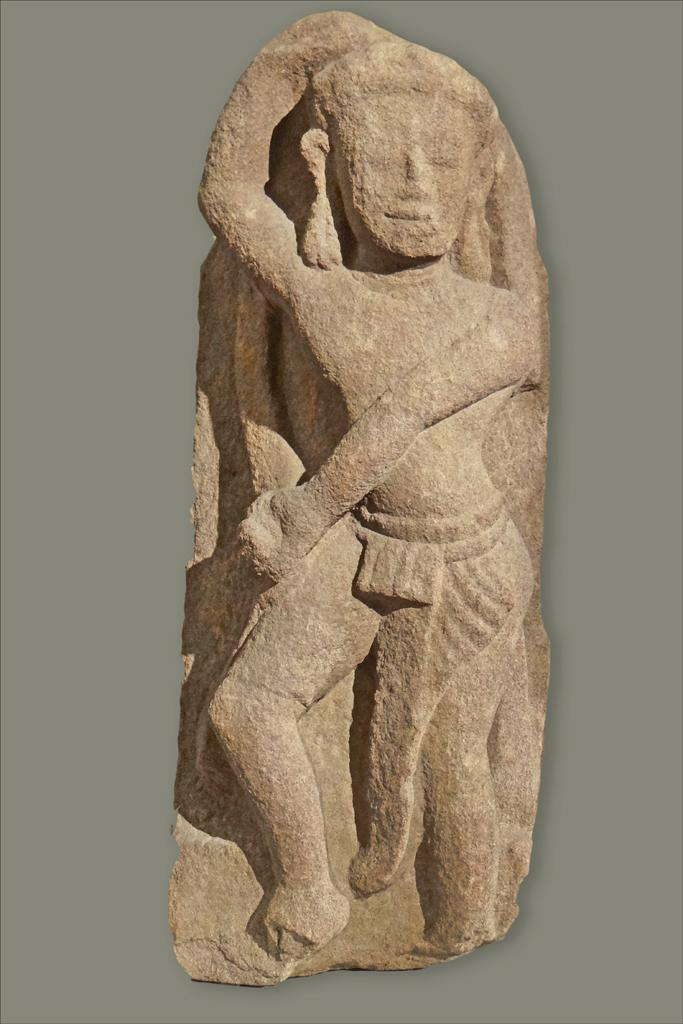What is the main subject of the image? There is a sculpture in the image. What material is the sculpture made of? The sculpture is made out of stone. What type of suit is the sculpture wearing in the image? The sculpture is made of stone and does not wear a suit or any clothing. Is there any produce visible in the image? There is no produce present in the image; it features a stone sculpture. 